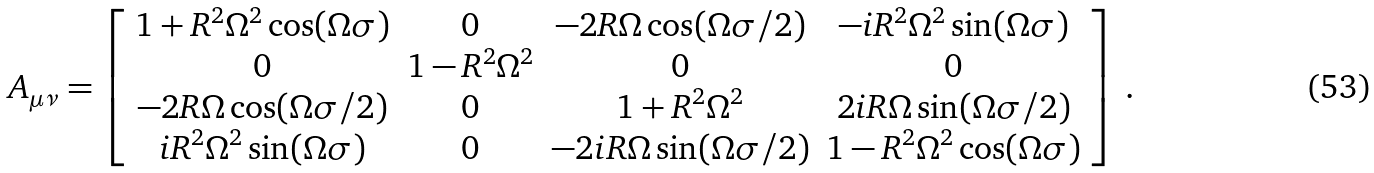<formula> <loc_0><loc_0><loc_500><loc_500>A _ { \mu \nu } = \left [ \begin{array} { c c c c } 1 + R ^ { 2 } \Omega ^ { 2 } \cos ( \Omega \sigma ) & 0 & - 2 R \Omega \cos ( \Omega \sigma / 2 ) & - i R ^ { 2 } \Omega ^ { 2 } \sin ( \Omega \sigma ) \\ 0 & 1 - R ^ { 2 } \Omega ^ { 2 } & 0 & 0 \\ - 2 R \Omega \cos ( \Omega \sigma / 2 ) & 0 & 1 + R ^ { 2 } \Omega ^ { 2 } & 2 i R \Omega \sin ( \Omega \sigma / 2 ) \\ i R ^ { 2 } \Omega ^ { 2 } \sin ( \Omega \sigma ) & 0 & - 2 i R \Omega \sin ( \Omega \sigma / 2 ) & 1 - R ^ { 2 } \Omega ^ { 2 } \cos ( \Omega \sigma ) \end{array} \right ] \, .</formula> 